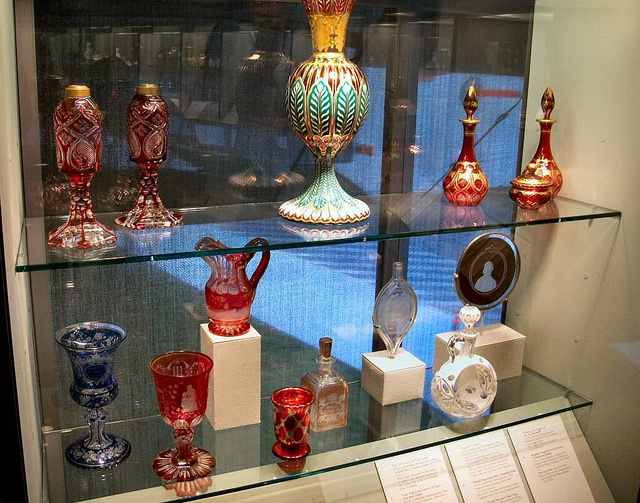Describe the objects in this image and their specific colors. I can see vase in tan, ivory, black, brown, and maroon tones, bottle in tan, maroon, black, brown, and gray tones, wine glass in tan, black, gray, and darkgray tones, wine glass in tan, maroon, and brown tones, and vase in tan, maroon, black, and brown tones in this image. 